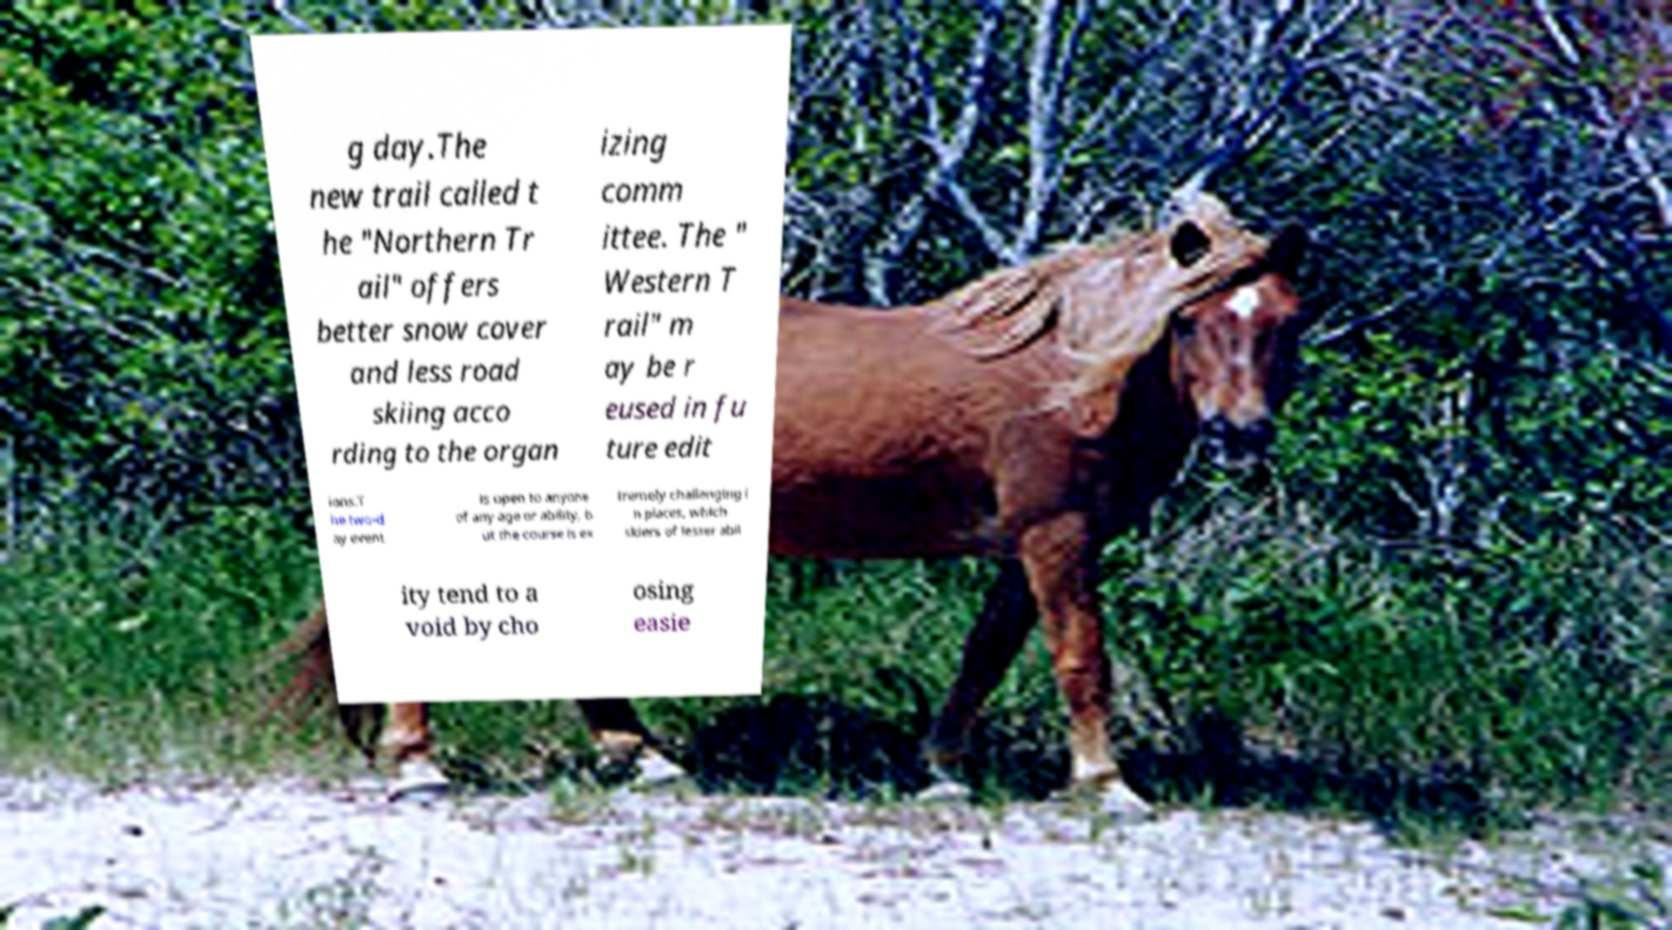There's text embedded in this image that I need extracted. Can you transcribe it verbatim? g day.The new trail called t he "Northern Tr ail" offers better snow cover and less road skiing acco rding to the organ izing comm ittee. The " Western T rail" m ay be r eused in fu ture edit ions.T he two-d ay event is open to anyone of any age or ability, b ut the course is ex tremely challenging i n places, which skiers of lesser abil ity tend to a void by cho osing easie 